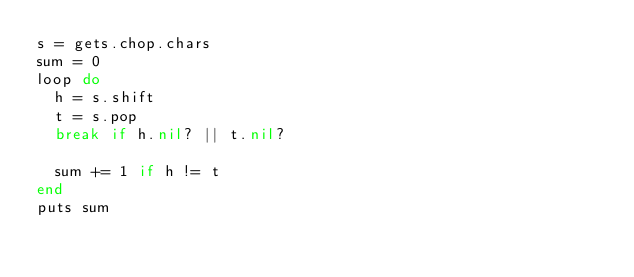<code> <loc_0><loc_0><loc_500><loc_500><_Ruby_>s = gets.chop.chars
sum = 0
loop do
  h = s.shift
  t = s.pop
  break if h.nil? || t.nil?

  sum += 1 if h != t
end
puts sum</code> 